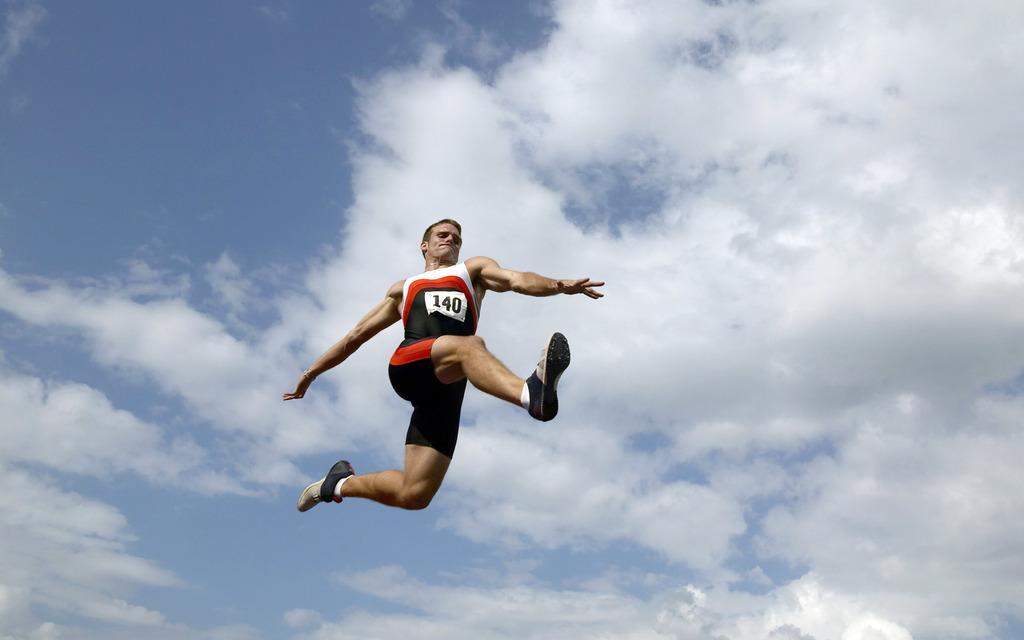How would you summarize this image in a sentence or two? This picture is clicked outside. In the center we can see a person wearing a t-shirt and jumping and we can see the numbers on the t-shirt. In the background we can see the sky with the clouds. 